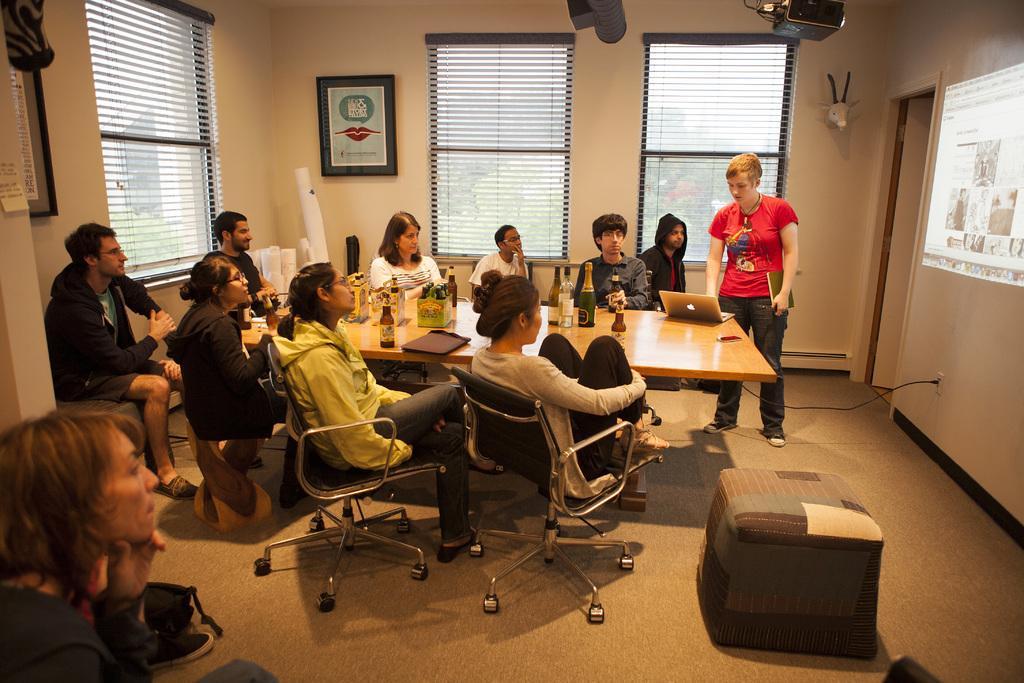Can you describe this image briefly? This picture shows some people sitting in the chairs around a table. On the table there are some laptops, bottles, files and glasses were present. There is a woman standing in front of a laptop. In the background there are some Windows and some photo frames attached to the wall here. 